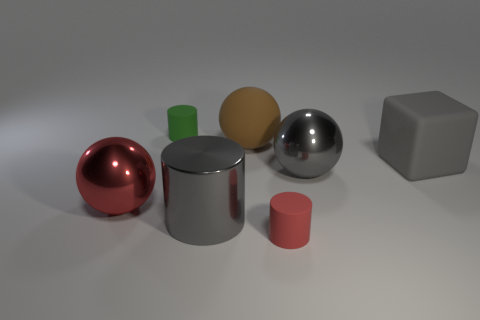Subtract all matte spheres. How many spheres are left? 2 Subtract all red cylinders. How many cylinders are left? 2 Subtract all cylinders. How many objects are left? 4 Subtract 1 cylinders. How many cylinders are left? 2 Add 1 big yellow metallic things. How many big yellow metallic things exist? 1 Add 2 large green balls. How many objects exist? 9 Subtract 0 cyan blocks. How many objects are left? 7 Subtract all cyan cylinders. Subtract all green cubes. How many cylinders are left? 3 Subtract all cyan cubes. How many gray balls are left? 1 Subtract all big gray shiny things. Subtract all green things. How many objects are left? 4 